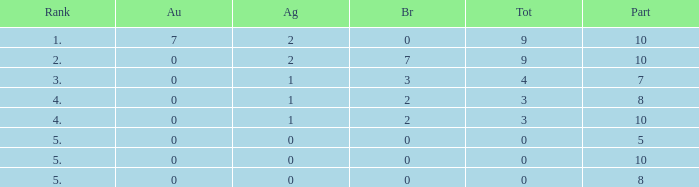What is listed as the highest Rank that has a Gold that's larger than 0, and Participants that's smaller than 10? None. 